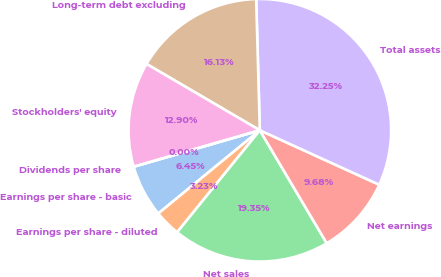<chart> <loc_0><loc_0><loc_500><loc_500><pie_chart><fcel>Earnings per share - basic<fcel>Earnings per share - diluted<fcel>Net sales<fcel>Net earnings<fcel>Total assets<fcel>Long-term debt excluding<fcel>Stockholders' equity<fcel>Dividends per share<nl><fcel>6.45%<fcel>3.23%<fcel>19.35%<fcel>9.68%<fcel>32.25%<fcel>16.13%<fcel>12.9%<fcel>0.0%<nl></chart> 